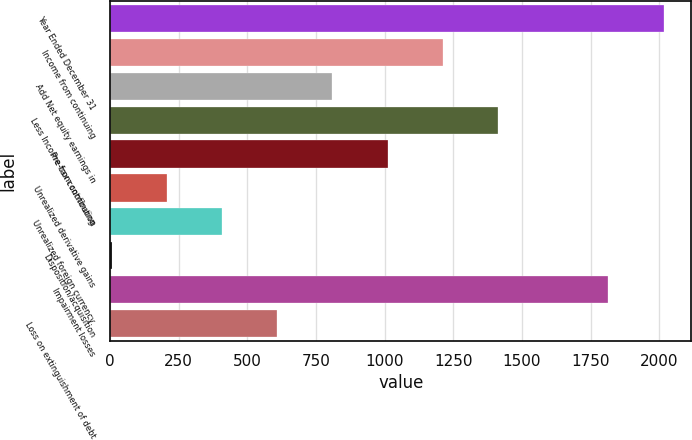<chart> <loc_0><loc_0><loc_500><loc_500><bar_chart><fcel>Year Ended December 31<fcel>Income from continuing<fcel>Add Net equity earnings in<fcel>Less Income from continuing<fcel>Pre-tax contribution<fcel>Unrealized derivative gains<fcel>Unrealized foreign currency<fcel>Disposition/acquisition<fcel>Impairment losses<fcel>Loss on extinguishment of debt<nl><fcel>2016<fcel>1212<fcel>810<fcel>1413<fcel>1011<fcel>207<fcel>408<fcel>6<fcel>1815<fcel>609<nl></chart> 